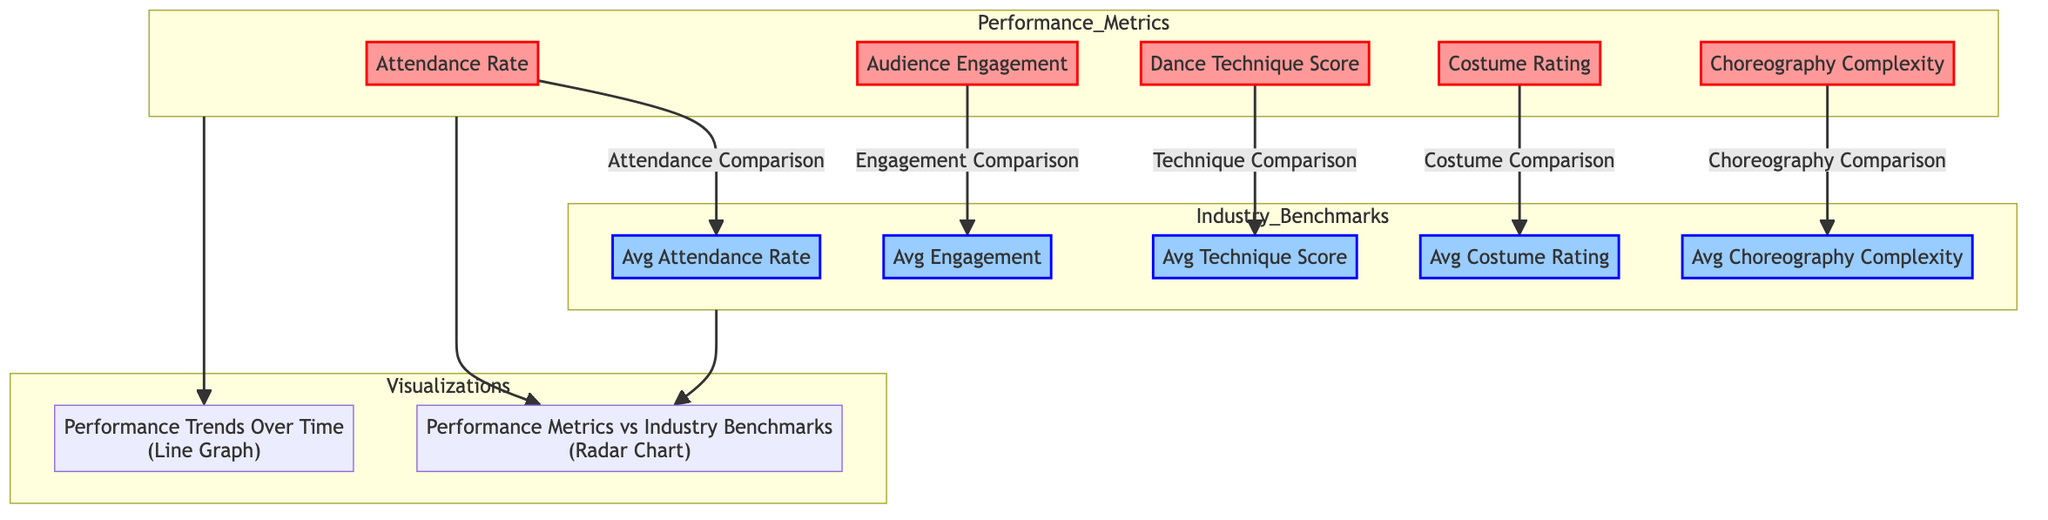What are the nodes in the Performance Metrics subgraph? The Performance Metrics subgraph contains five nodes: Attendance Rate, Audience Engagement, Dance Technique Score, Costume Rating, and Choreography Complexity.
Answer: Attendance Rate, Audience Engagement, Dance Technique Score, Costume Rating, Choreography Complexity What metric is compared to the average attendance? The Attendance Rate is directly compared to the Avg Attendance Rate node in the diagram.
Answer: Attendance Rate Which visualization shows the relationship between performance metrics and industry benchmarks? The radar chart visualizes how the Performance Metrics compare to the Industry Benchmarks, as indicated by the connection from both subgraphs to the radar chart node.
Answer: Radar Chart How many metrics are used for comparison against industry benchmarks? There are five metrics listed in the Performance Metrics subgraph that are compared to the corresponding industry benchmarks.
Answer: Five What flows from the Dance Technique Score to the Avg Technique Score? The flow from Dance Technique Score leads to Avg Technique Score, indicating a direct comparison between these two nodes.
Answer: Technique Comparison Which node represents the complexity of choreography in the analysis? The Choreography Complexity node represents the complexity of choreography being evaluated in the analysis.
Answer: Choreography Complexity What two visualizations are included in the diagram? The diagram includes two visualizations: the radar chart and the line graph, showing different aspects of performance metrics.
Answer: Radar Chart and Line Graph What does the line graph illustrate according to the diagram? The line graph illustrates performance trends over time as indicated in the Visualizations subgraph.
Answer: Performance Trends Over Time How do the performance metrics relate to the industry benchmarks? Each performance metric is connected to its corresponding industry benchmark through comparative comparisons that indicate how well the metrics fare against the industry standards.
Answer: Comparative Analysis 